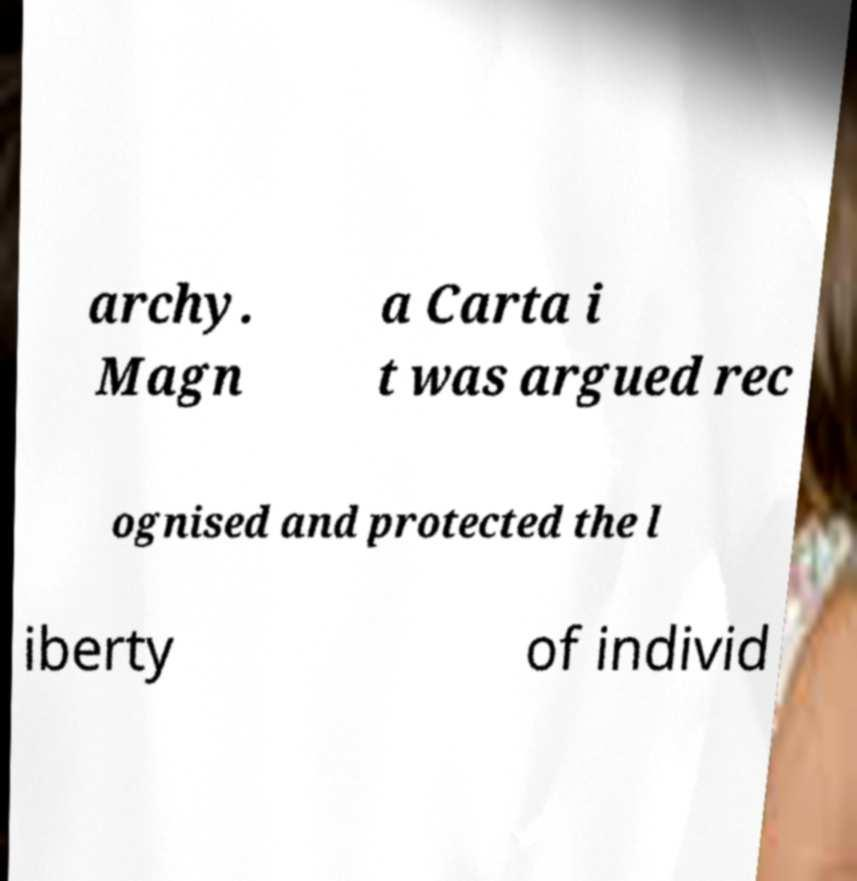For documentation purposes, I need the text within this image transcribed. Could you provide that? archy. Magn a Carta i t was argued rec ognised and protected the l iberty of individ 